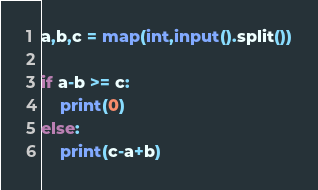Convert code to text. <code><loc_0><loc_0><loc_500><loc_500><_Python_>a,b,c = map(int,input().split())

if a-b >= c:
    print(0)
else:
    print(c-a+b)</code> 